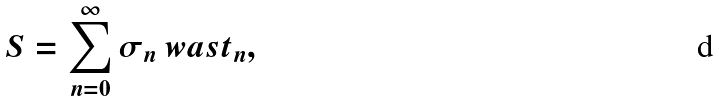Convert formula to latex. <formula><loc_0><loc_0><loc_500><loc_500>S = \sum _ { n = 0 } ^ { \infty } \sigma _ { n } \ w a s t _ { n } ,</formula> 